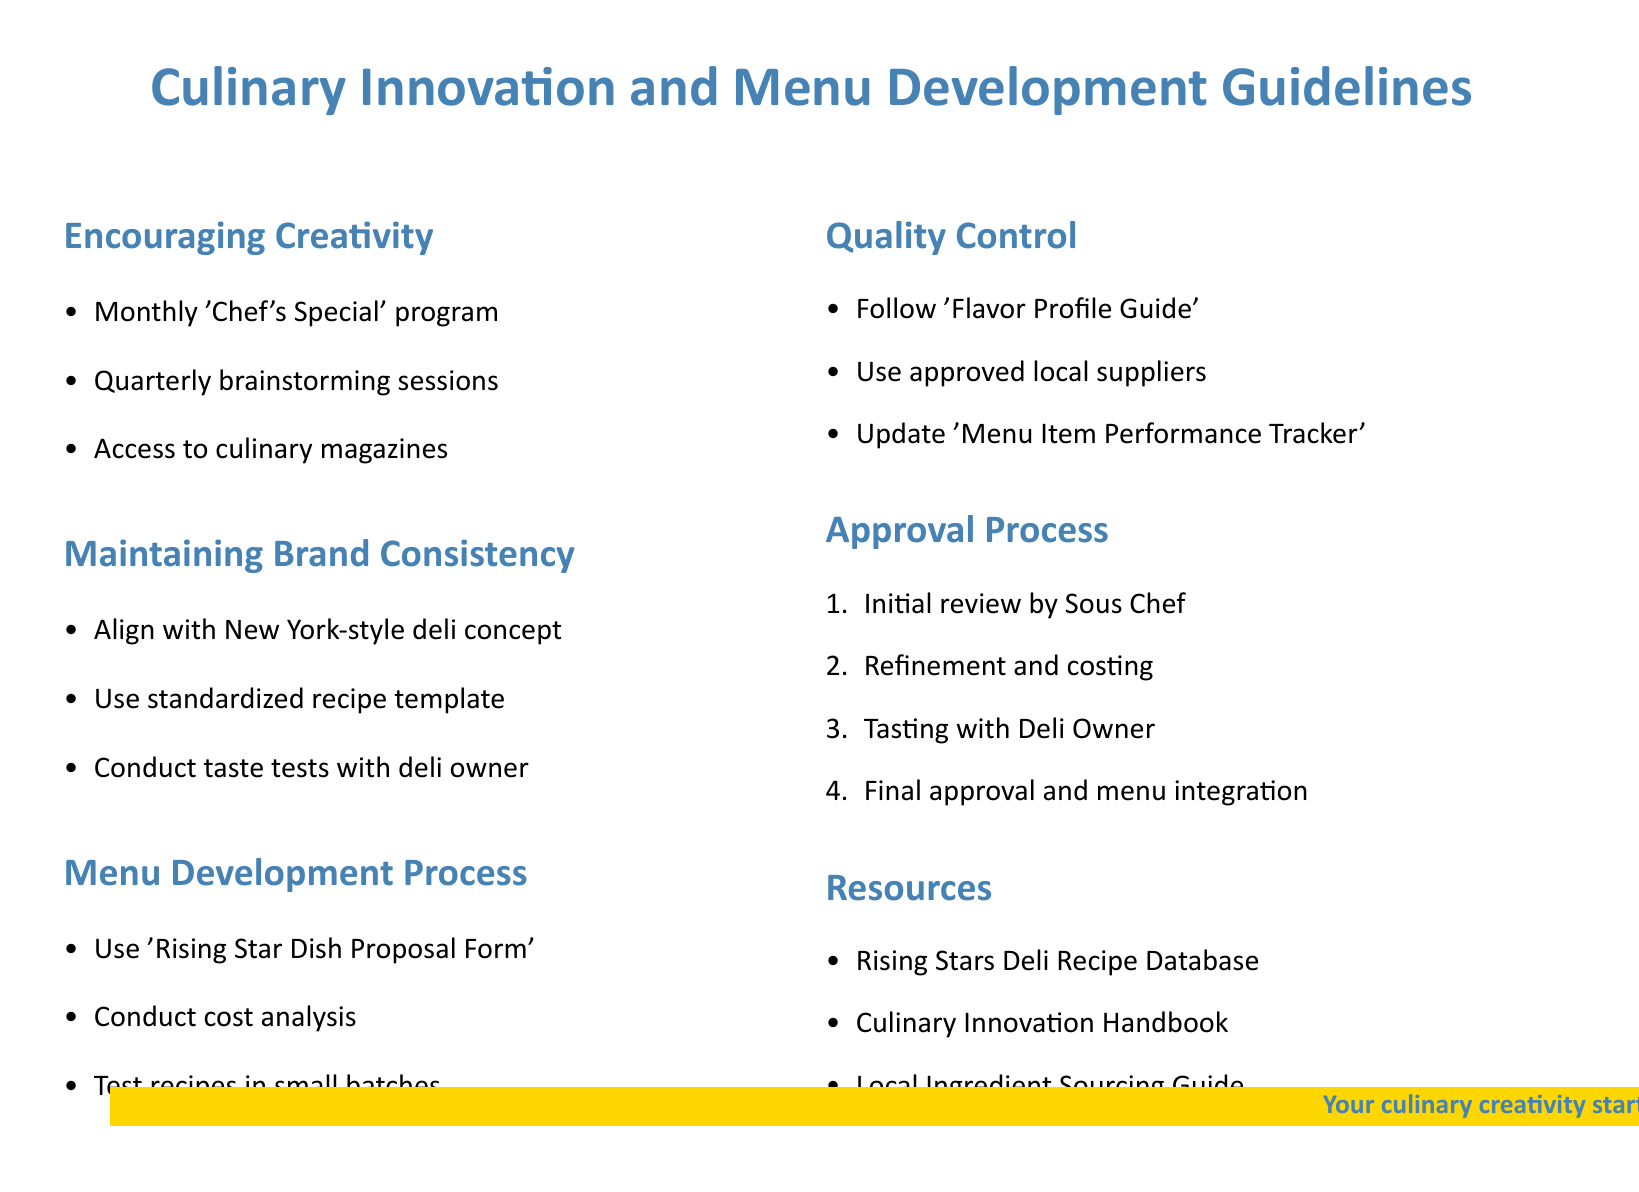What is the title of the document? The title of the document is typically given at the top, which is "Culinary Innovation and Menu Development Guidelines."
Answer: Culinary Innovation and Menu Development Guidelines What is the color used for headings in the document? The document uses a specific color for headings, which is defined as "deliblue."
Answer: deliblue How often are brainstorming sessions held? The document specifies that brainstorming sessions are held quarterly.
Answer: quarterly What is the first step in the approval process? The approval process starts with an initial review by the Sous Chef.
Answer: Initial review by Sous Chef Where can one find the recipe database? The document mentions a specific resource, which is the "Rising Stars Deli Recipe Database."
Answer: Rising Stars Deli Recipe Database What document template is recommended for recipes? The document recommends using a "standardized recipe template."
Answer: standardized recipe template What should be used for conducting taste tests? The taste tests should be conducted with the Deli Owner as stated in the guidelines.
Answer: Deli Owner How many items are in the quality control section? The quality control section consists of three items outlined in the document.
Answer: three 